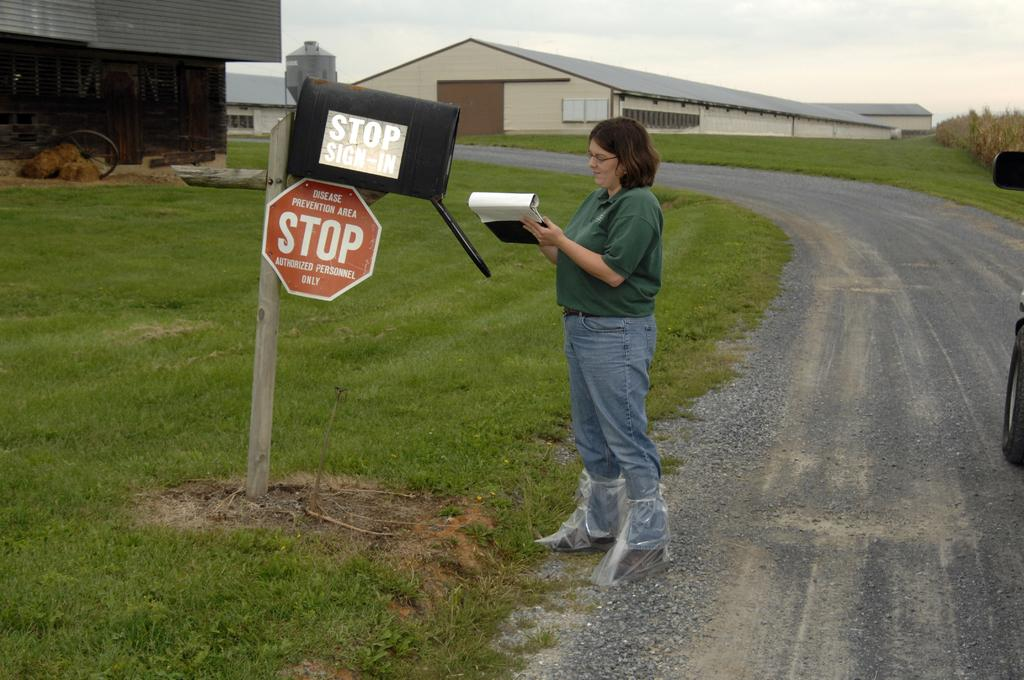Provide a one-sentence caption for the provided image. a person standing next to a stop sign. 